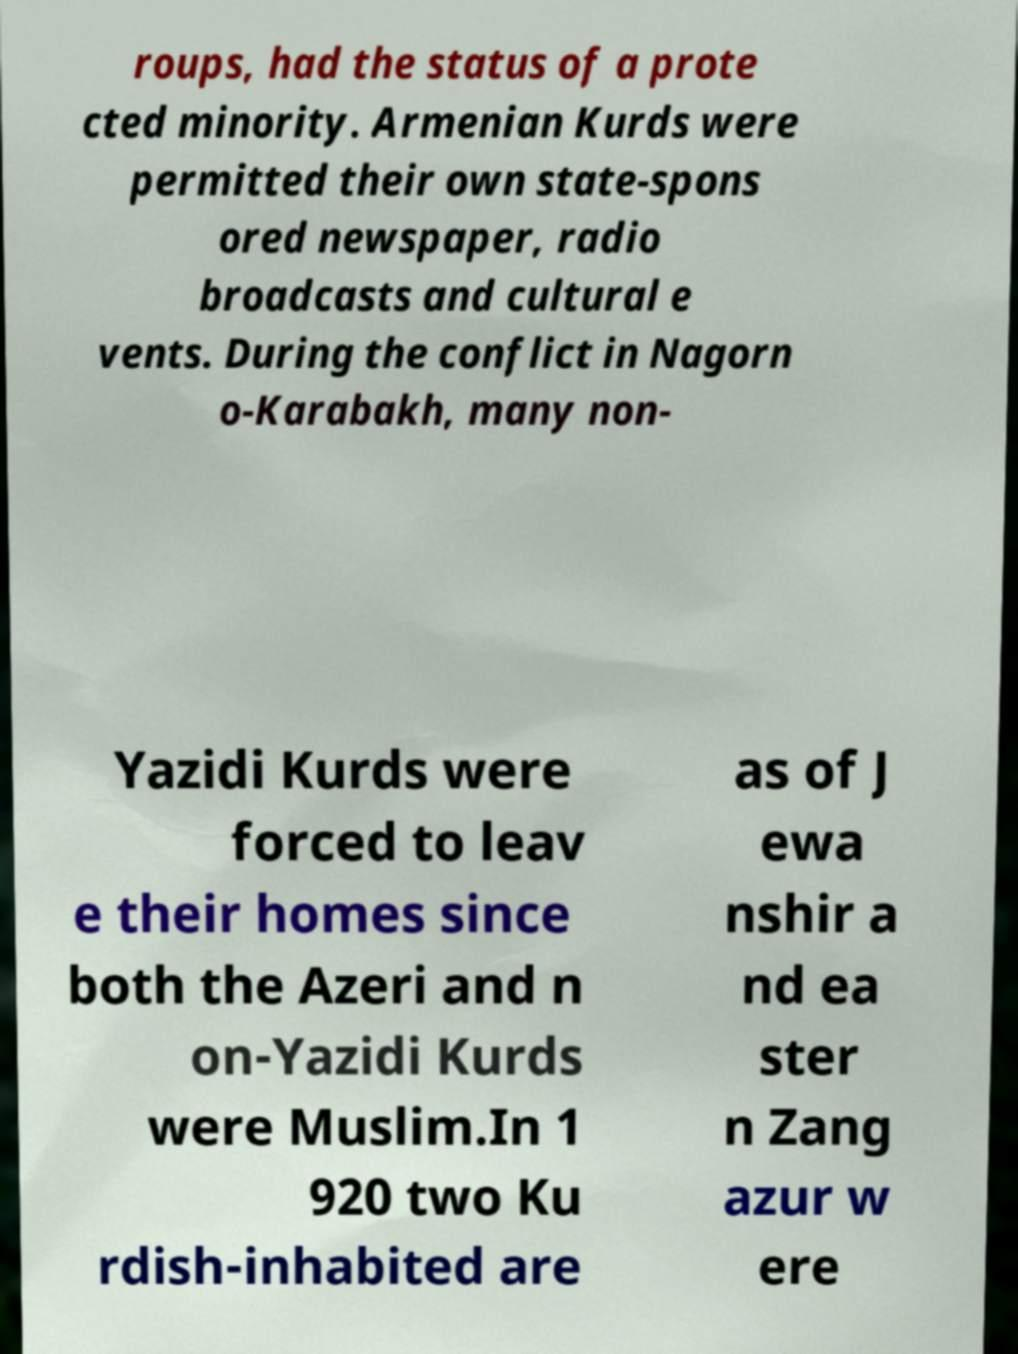For documentation purposes, I need the text within this image transcribed. Could you provide that? roups, had the status of a prote cted minority. Armenian Kurds were permitted their own state-spons ored newspaper, radio broadcasts and cultural e vents. During the conflict in Nagorn o-Karabakh, many non- Yazidi Kurds were forced to leav e their homes since both the Azeri and n on-Yazidi Kurds were Muslim.In 1 920 two Ku rdish-inhabited are as of J ewa nshir a nd ea ster n Zang azur w ere 